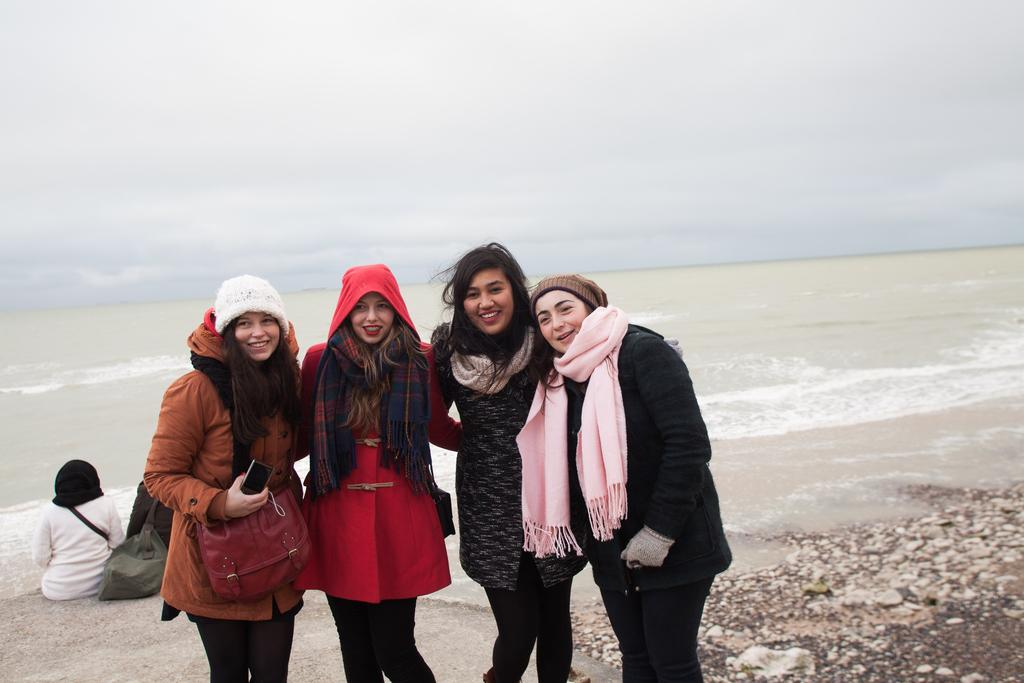What are the women in the image doing? The women in the image are standing and smiling. What is one of the women holding? One of the women is holding a mobile. What else is the woman holding the mobile wearing? The woman holding the mobile is also wearing a bag. What can be seen in the background of the image? In the background, there are people sitting, a bag, water, and the sky. How many fingers can be seen on the woman holding the mobile in the image? There is no information about the number of fingers visible on the woman holding the mobile in the image. 